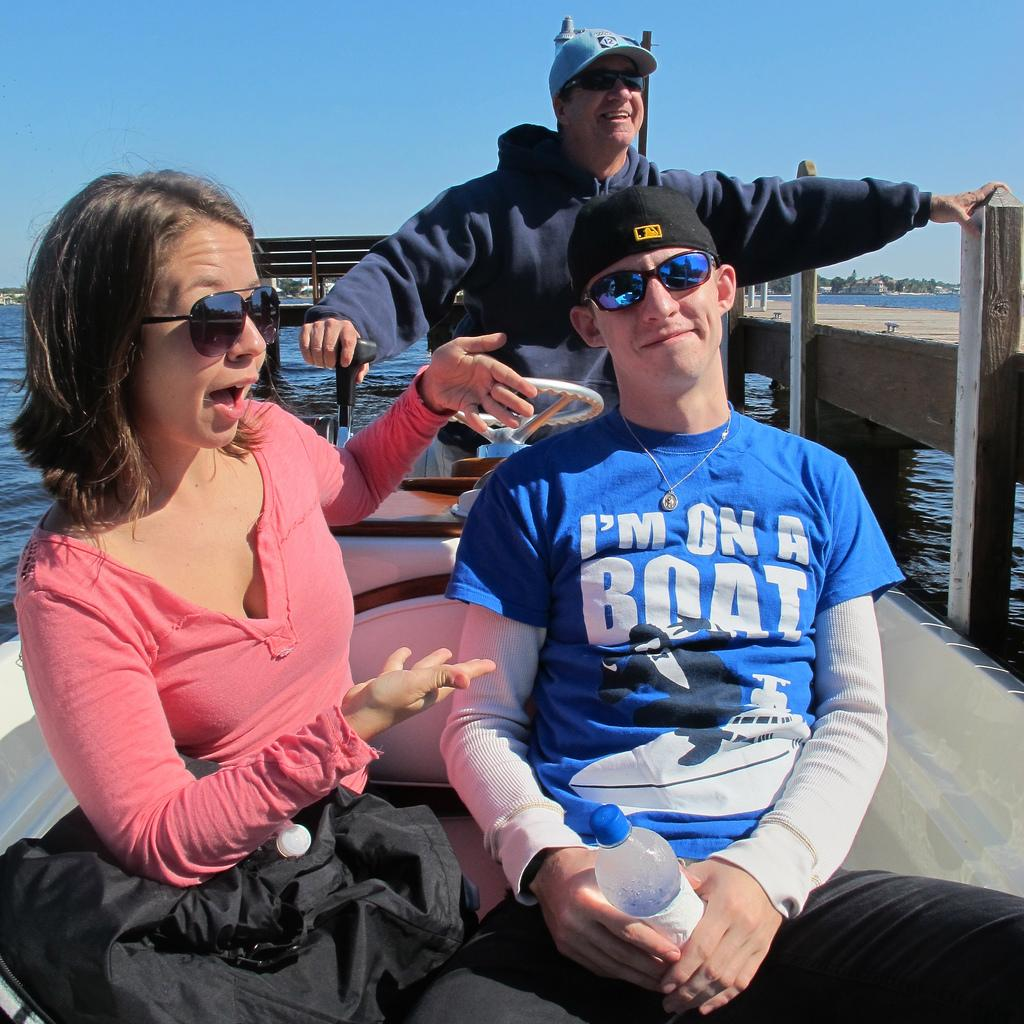<image>
Relay a brief, clear account of the picture shown. A young man on a boat wears a t-shirt which says he's on a boat. 